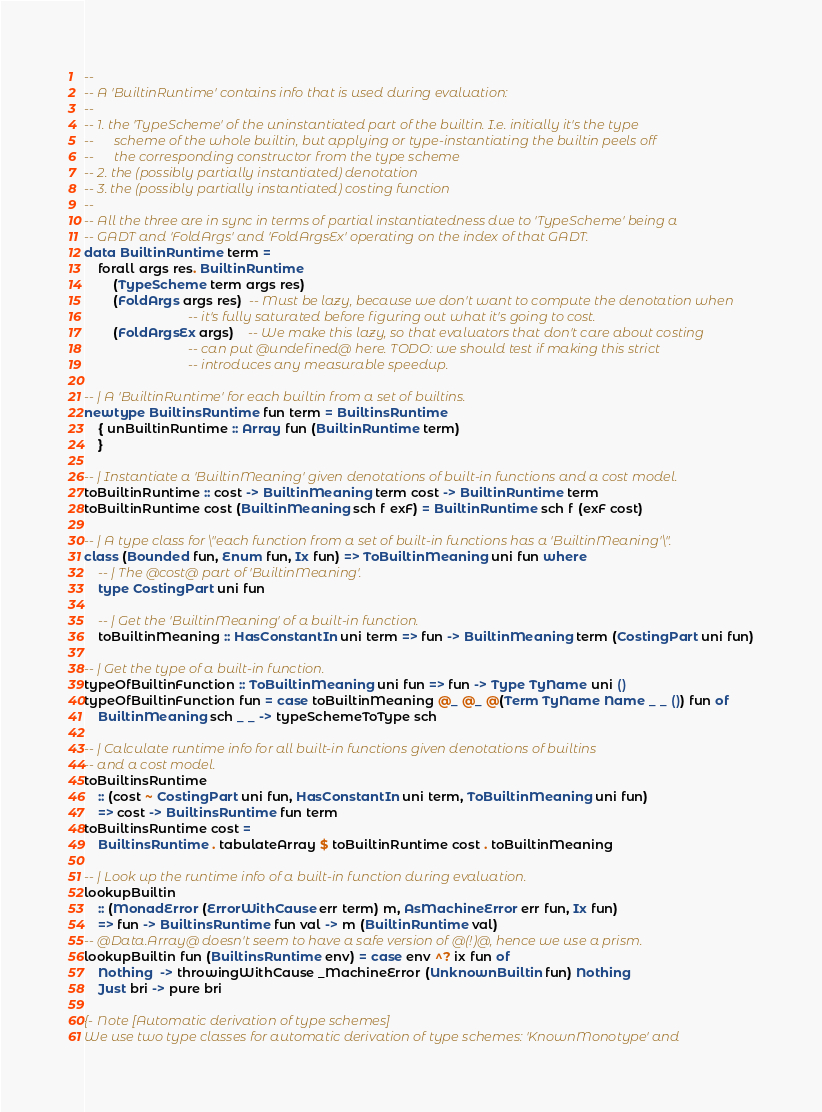Convert code to text. <code><loc_0><loc_0><loc_500><loc_500><_Haskell_>--
-- A 'BuiltinRuntime' contains info that is used during evaluation:
--
-- 1. the 'TypeScheme' of the uninstantiated part of the builtin. I.e. initially it's the type
--      scheme of the whole builtin, but applying or type-instantiating the builtin peels off
--      the corresponding constructor from the type scheme
-- 2. the (possibly partially instantiated) denotation
-- 3. the (possibly partially instantiated) costing function
--
-- All the three are in sync in terms of partial instantiatedness due to 'TypeScheme' being a
-- GADT and 'FoldArgs' and 'FoldArgsEx' operating on the index of that GADT.
data BuiltinRuntime term =
    forall args res. BuiltinRuntime
        (TypeScheme term args res)
        (FoldArgs args res)  -- Must be lazy, because we don't want to compute the denotation when
                             -- it's fully saturated before figuring out what it's going to cost.
        (FoldArgsEx args)    -- We make this lazy, so that evaluators that don't care about costing
                             -- can put @undefined@ here. TODO: we should test if making this strict
                             -- introduces any measurable speedup.

-- | A 'BuiltinRuntime' for each builtin from a set of builtins.
newtype BuiltinsRuntime fun term = BuiltinsRuntime
    { unBuiltinRuntime :: Array fun (BuiltinRuntime term)
    }

-- | Instantiate a 'BuiltinMeaning' given denotations of built-in functions and a cost model.
toBuiltinRuntime :: cost -> BuiltinMeaning term cost -> BuiltinRuntime term
toBuiltinRuntime cost (BuiltinMeaning sch f exF) = BuiltinRuntime sch f (exF cost)

-- | A type class for \"each function from a set of built-in functions has a 'BuiltinMeaning'\".
class (Bounded fun, Enum fun, Ix fun) => ToBuiltinMeaning uni fun where
    -- | The @cost@ part of 'BuiltinMeaning'.
    type CostingPart uni fun

    -- | Get the 'BuiltinMeaning' of a built-in function.
    toBuiltinMeaning :: HasConstantIn uni term => fun -> BuiltinMeaning term (CostingPart uni fun)

-- | Get the type of a built-in function.
typeOfBuiltinFunction :: ToBuiltinMeaning uni fun => fun -> Type TyName uni ()
typeOfBuiltinFunction fun = case toBuiltinMeaning @_ @_ @(Term TyName Name _ _ ()) fun of
    BuiltinMeaning sch _ _ -> typeSchemeToType sch

-- | Calculate runtime info for all built-in functions given denotations of builtins
-- and a cost model.
toBuiltinsRuntime
    :: (cost ~ CostingPart uni fun, HasConstantIn uni term, ToBuiltinMeaning uni fun)
    => cost -> BuiltinsRuntime fun term
toBuiltinsRuntime cost =
    BuiltinsRuntime . tabulateArray $ toBuiltinRuntime cost . toBuiltinMeaning

-- | Look up the runtime info of a built-in function during evaluation.
lookupBuiltin
    :: (MonadError (ErrorWithCause err term) m, AsMachineError err fun, Ix fun)
    => fun -> BuiltinsRuntime fun val -> m (BuiltinRuntime val)
-- @Data.Array@ doesn't seem to have a safe version of @(!)@, hence we use a prism.
lookupBuiltin fun (BuiltinsRuntime env) = case env ^? ix fun of
    Nothing  -> throwingWithCause _MachineError (UnknownBuiltin fun) Nothing
    Just bri -> pure bri

{- Note [Automatic derivation of type schemes]
We use two type classes for automatic derivation of type schemes: 'KnownMonotype' and</code> 